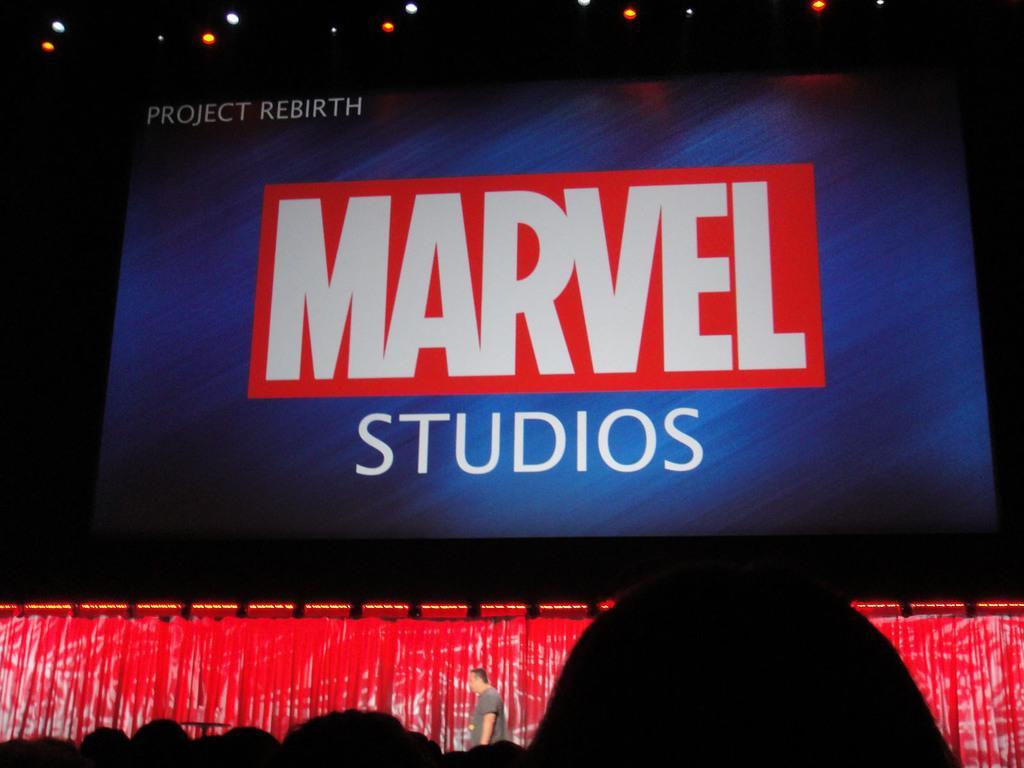In one or two sentences, can you explain what this image depicts? In this image there is a big display screen. There is text on the screen. Below to it there is a man standing. There are lights to the ceiling. The background is dark. 